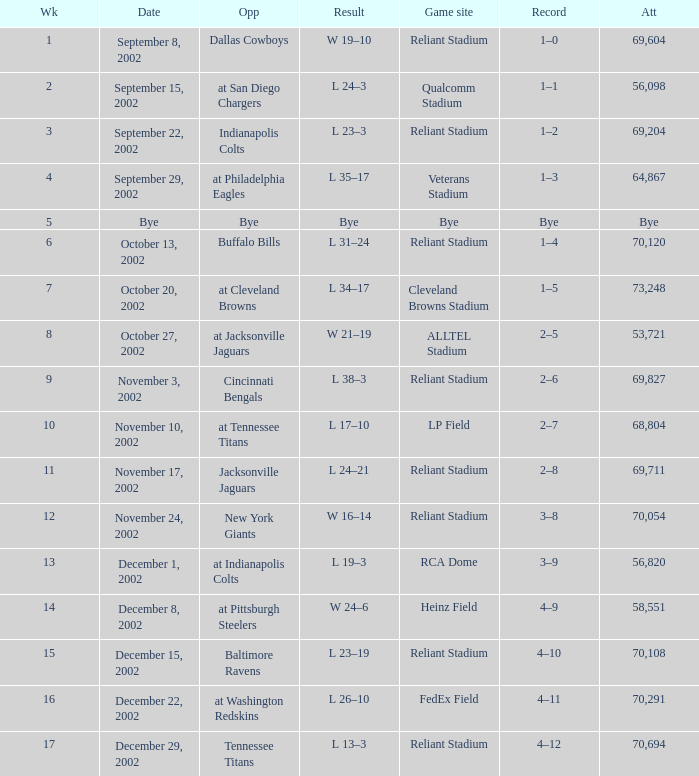What is the earliest week that the Texans played at the Cleveland Browns Stadium? 7.0. 